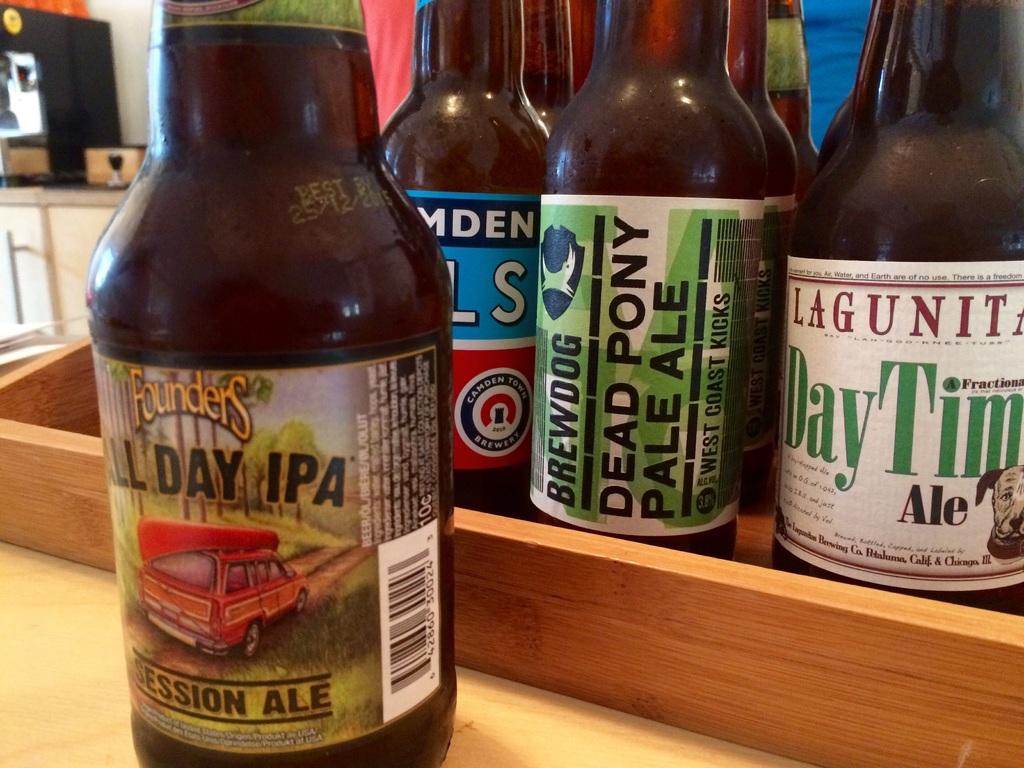What is the name of the ipa in front?
Your response must be concise. All day. 